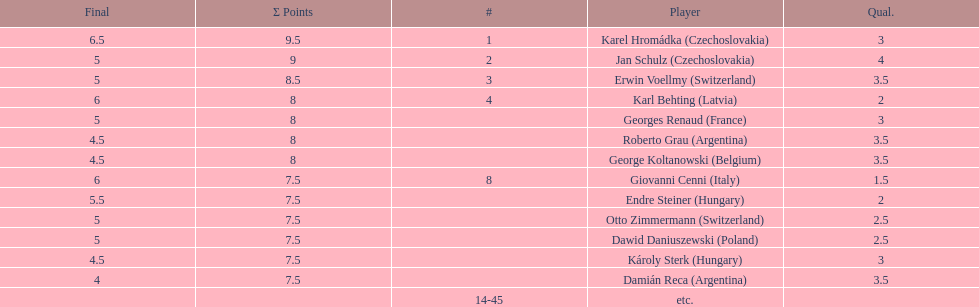How many players had a 8 points? 4. 